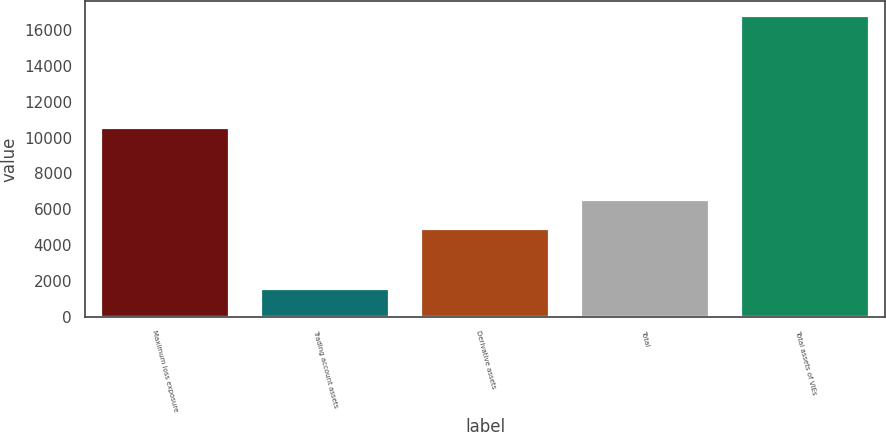Convert chart to OTSL. <chart><loc_0><loc_0><loc_500><loc_500><bar_chart><fcel>Maximum loss exposure<fcel>Trading account assets<fcel>Derivative assets<fcel>Total<fcel>Total assets of VIEs<nl><fcel>10506<fcel>1517<fcel>4893<fcel>6491<fcel>16764<nl></chart> 